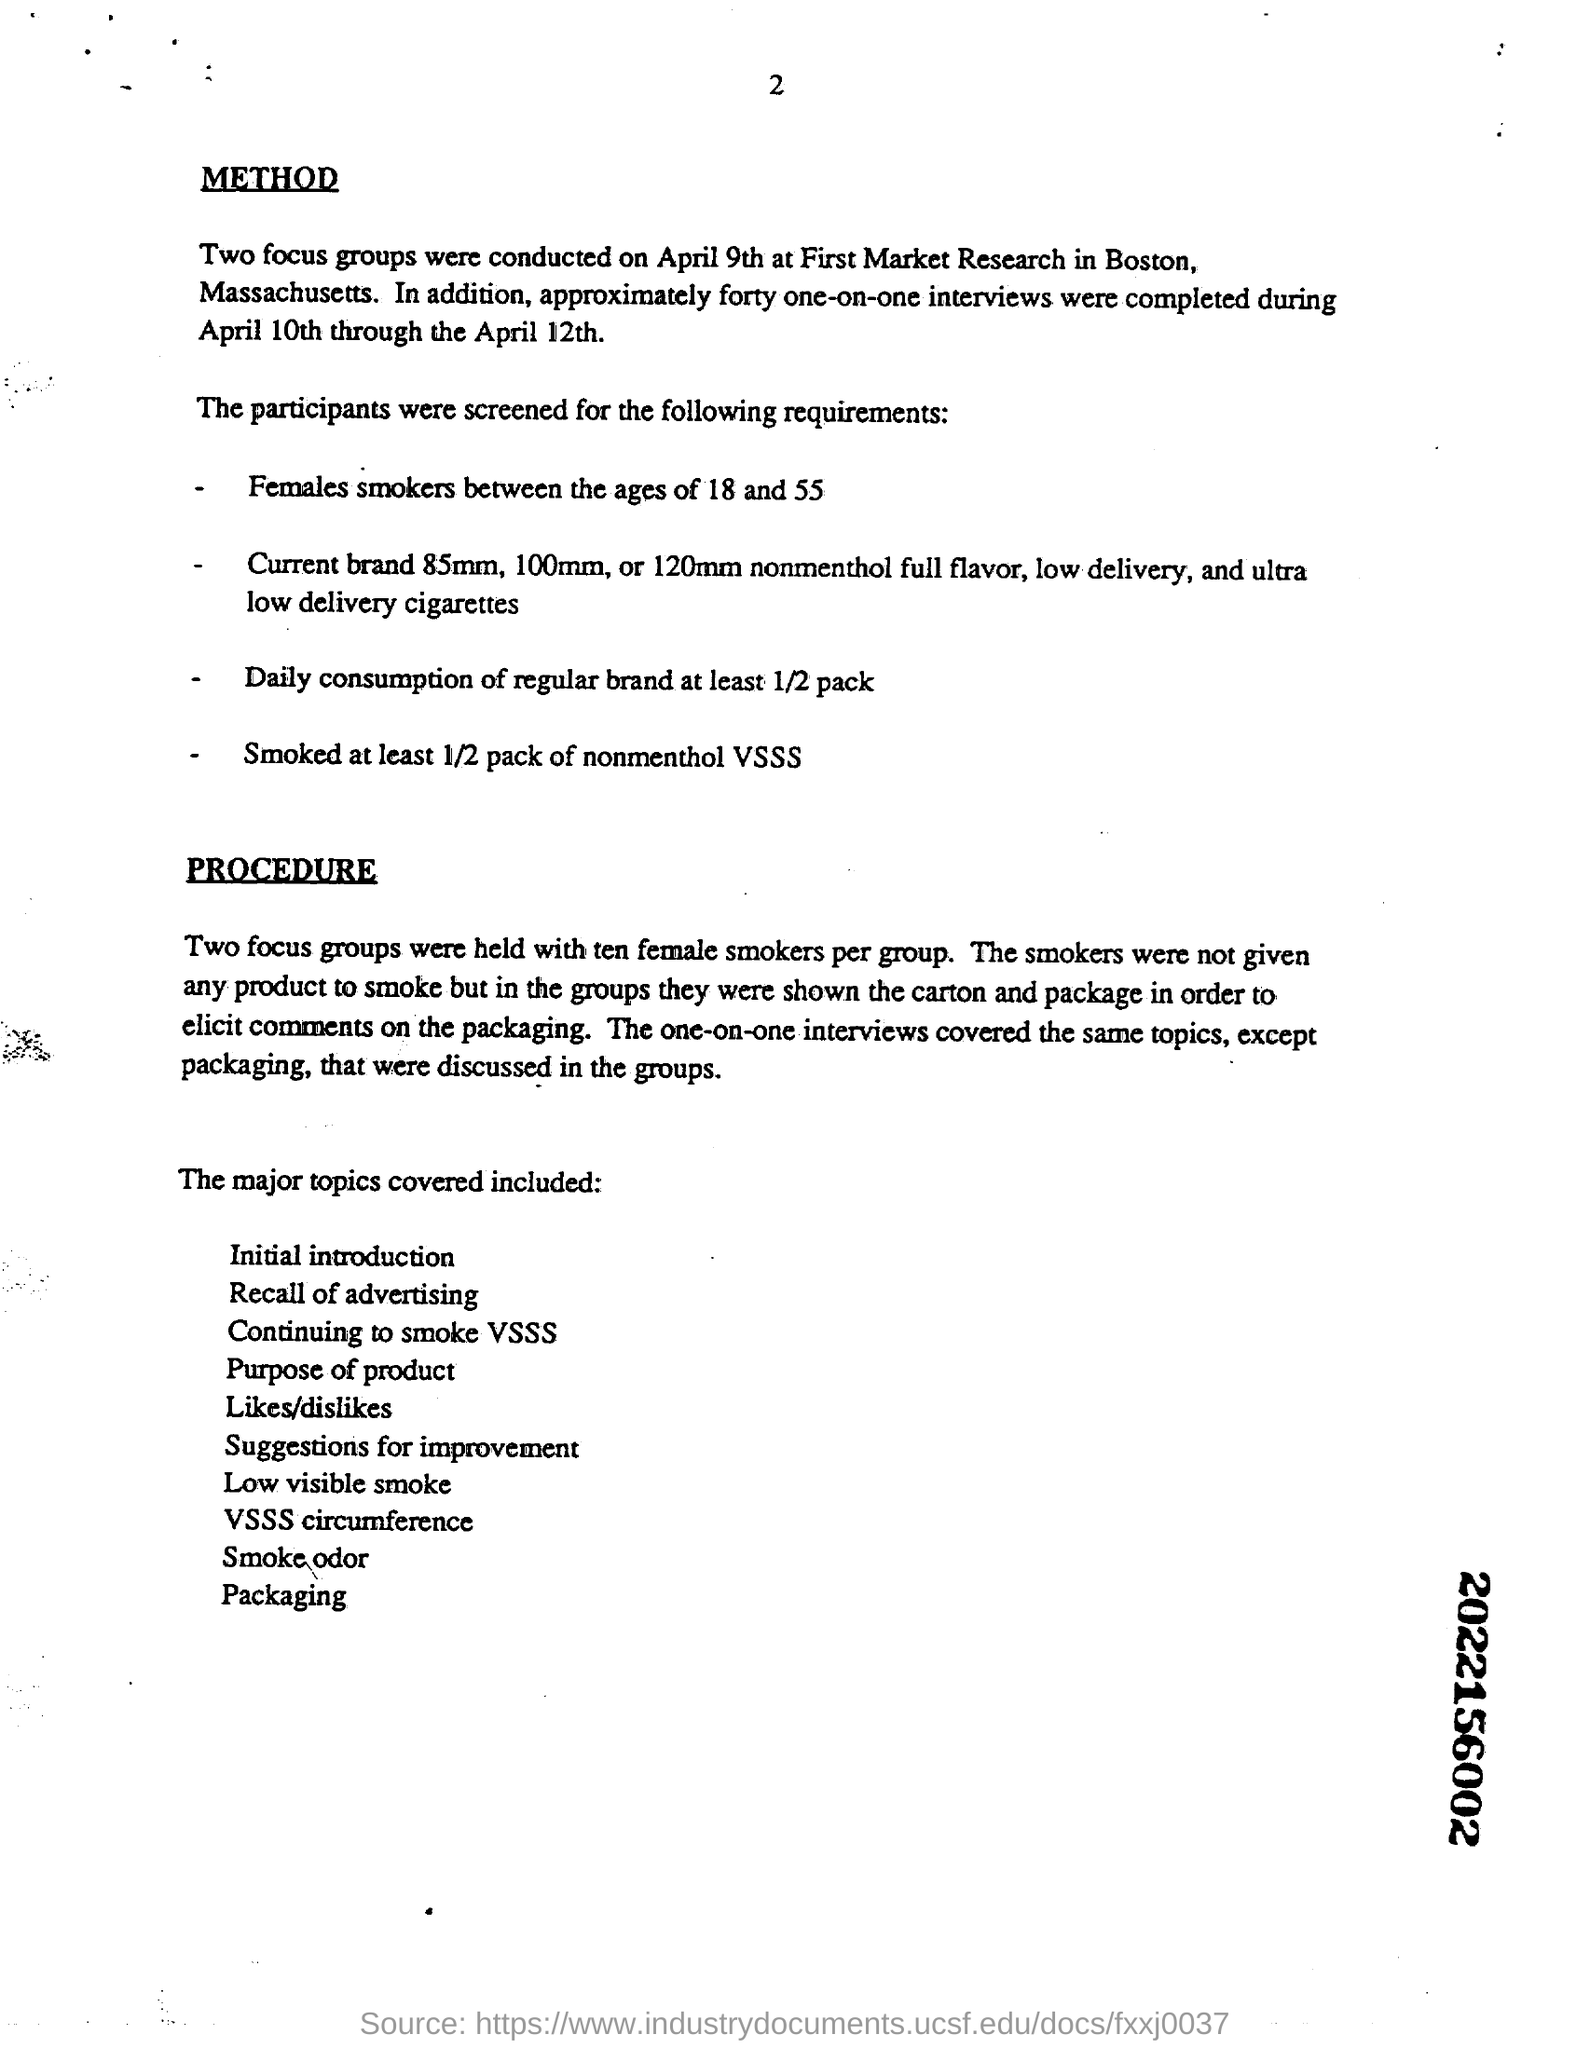How many one-on-one interviews were completed during April 10th through the April 12th? The document states that approximately forty one-on-one interviews were completed during the timeframe of April 10th through April 12th, as part of a research study conducted by First Market Research in Boston, Massachusetts. 